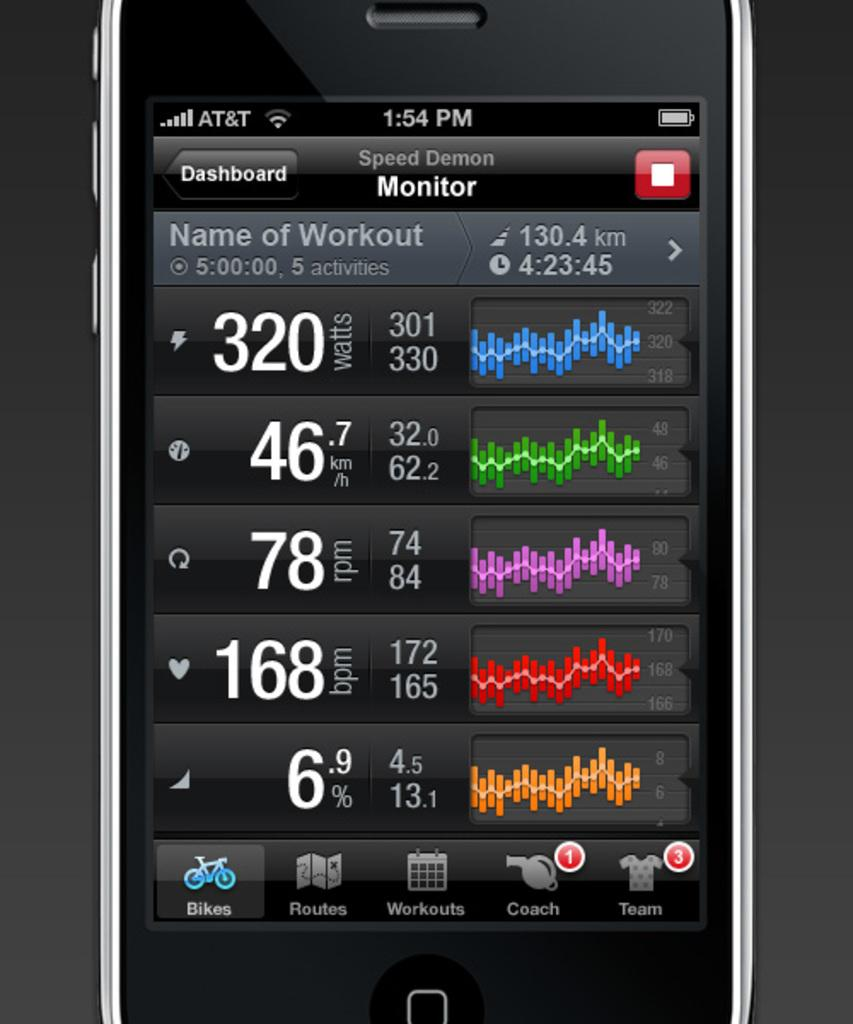<image>
Create a compact narrative representing the image presented. a phone that has the word coach on it 